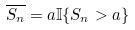<formula> <loc_0><loc_0><loc_500><loc_500>\overline { S _ { n } } = a \mathbb { I } \{ S _ { n } > a \}</formula> 